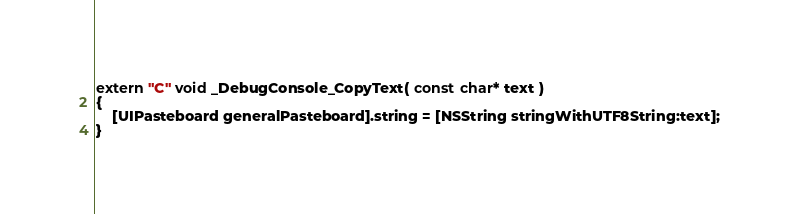Convert code to text. <code><loc_0><loc_0><loc_500><loc_500><_ObjectiveC_>extern "C" void _DebugConsole_CopyText( const char* text ) 
{
	[UIPasteboard generalPasteboard].string = [NSString stringWithUTF8String:text];
}</code> 